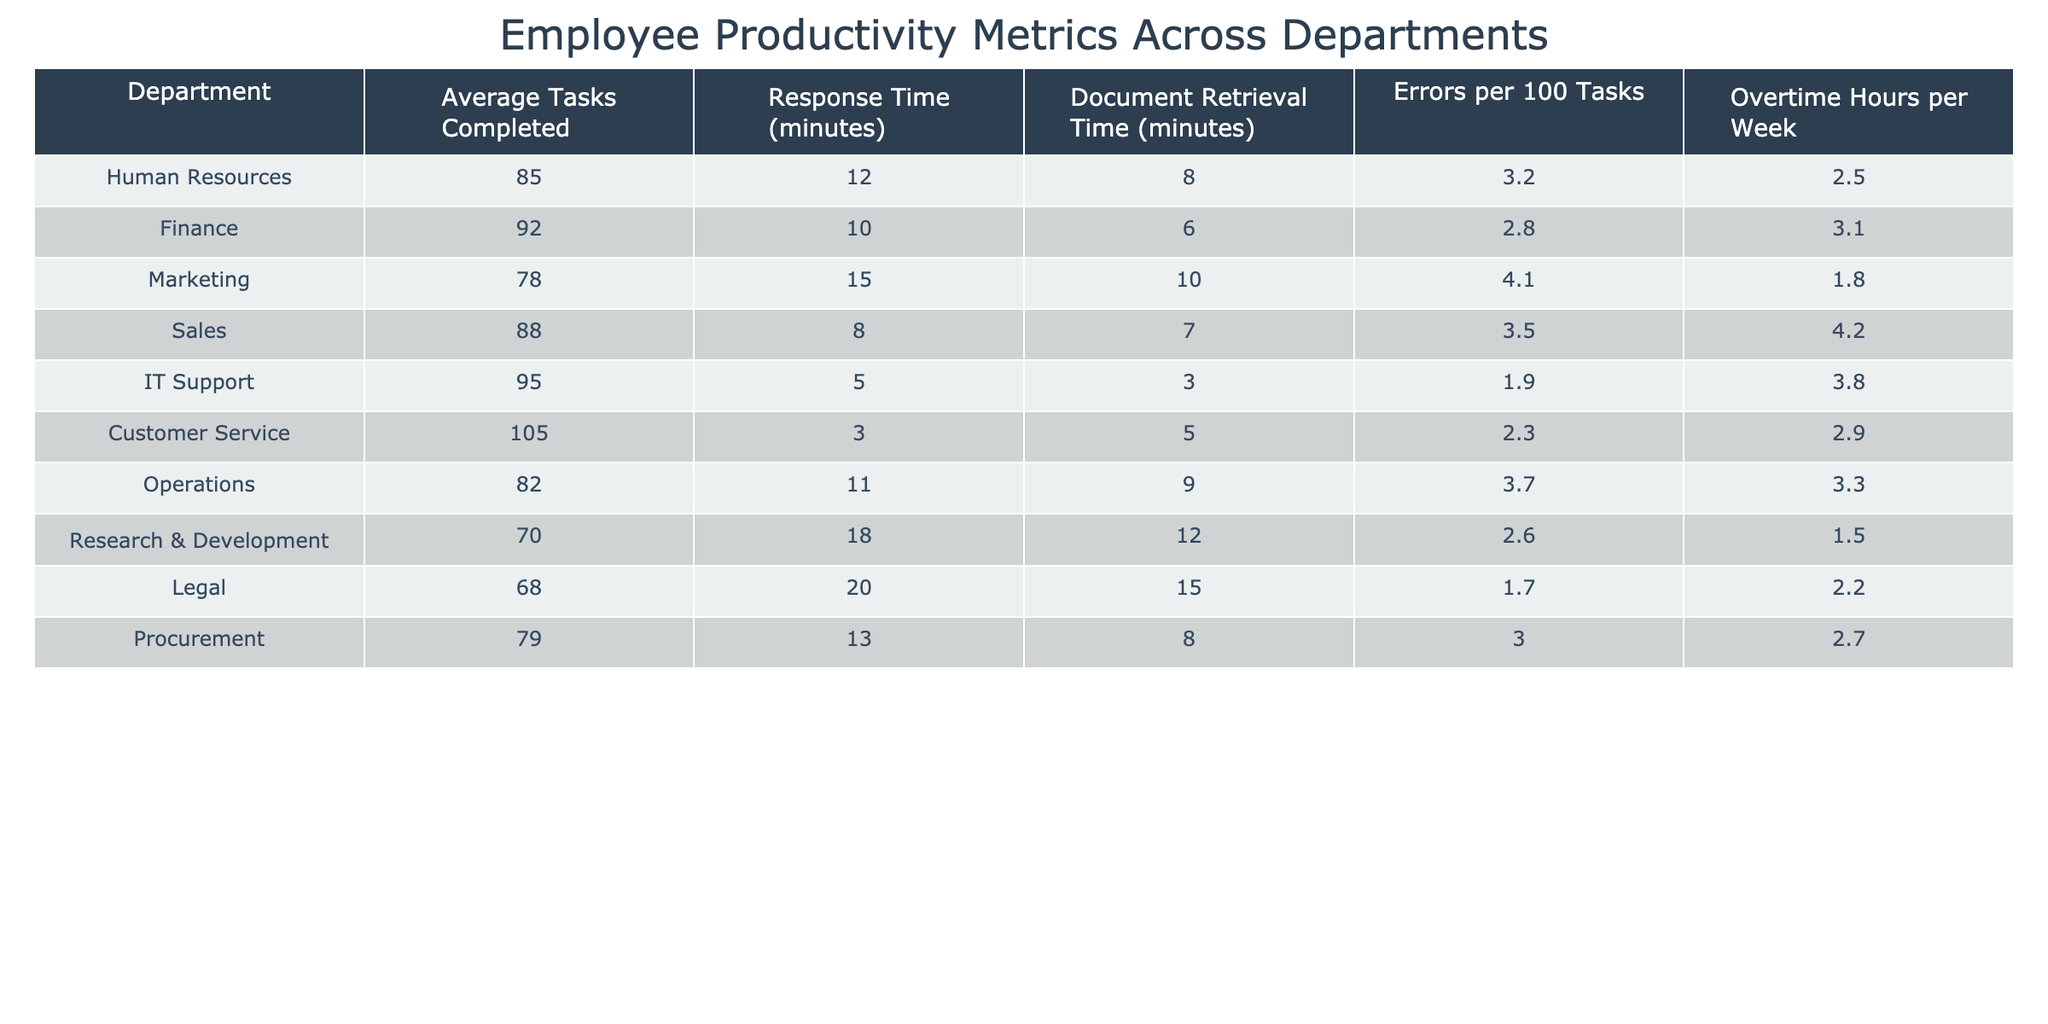What is the average number of tasks completed in the Sales department? Referring to the table, the average tasks completed in the Sales department is listed as 88.
Answer: 88 Which department has the lowest Response Time? According to the table, the IT Support department has the lowest Response Time at 5 minutes.
Answer: 5 minutes Is it true that the Customer Service department has a higher average tasks completed than the Finance department? The table shows that Customer Service has an average of 105 tasks completed while Finance has 92, confirming that it is true.
Answer: Yes What is the difference in Document Retrieval Time between the Legal and IT Support departments? Legal has a Document Retrieval Time of 15 minutes, while IT Support has 3 minutes. The difference is 15 - 3 = 12 minutes.
Answer: 12 minutes Which department has the highest number of Errors per 100 Tasks, and what is that number? The Marketing department shows the highest number of Errors per 100 Tasks at 4.1.
Answer: 4.1 What is the combined total of Overtime Hours per Week for both the Legal and Marketing departments? Legal has 2.2 hours and Marketing has 1.8 hours. Adding them gives us 2.2 + 1.8 = 4 hours.
Answer: 4 hours If the average Response Time of the Human Resources department is increased by 5 minutes, what would their new Response Time be? The current Response Time is 12 minutes. Increasing it by 5 results in 12 + 5 = 17 minutes.
Answer: 17 minutes Which department has more average tasks completed: Operations or Research & Development? Operations has 82 tasks completed while Research & Development has 70. Therefore, Operations has more.
Answer: Operations What is the average Response Time across all departments? Adding the Response Times gives (12 + 10 + 15 + 8 + 5 + 3 + 11 + 18 + 20 + 13) = 125 minutes. Dividing by the number of departments (10) gives 125 / 10 = 12.5 minutes.
Answer: 12.5 minutes Which departments have a Document Retrieval Time of under 9 minutes? The departments with Document Retrieval Times under 9 minutes are IT Support (3 minutes), Finance (6 minutes), and Sales (7 minutes).
Answer: IT Support, Finance, Sales 